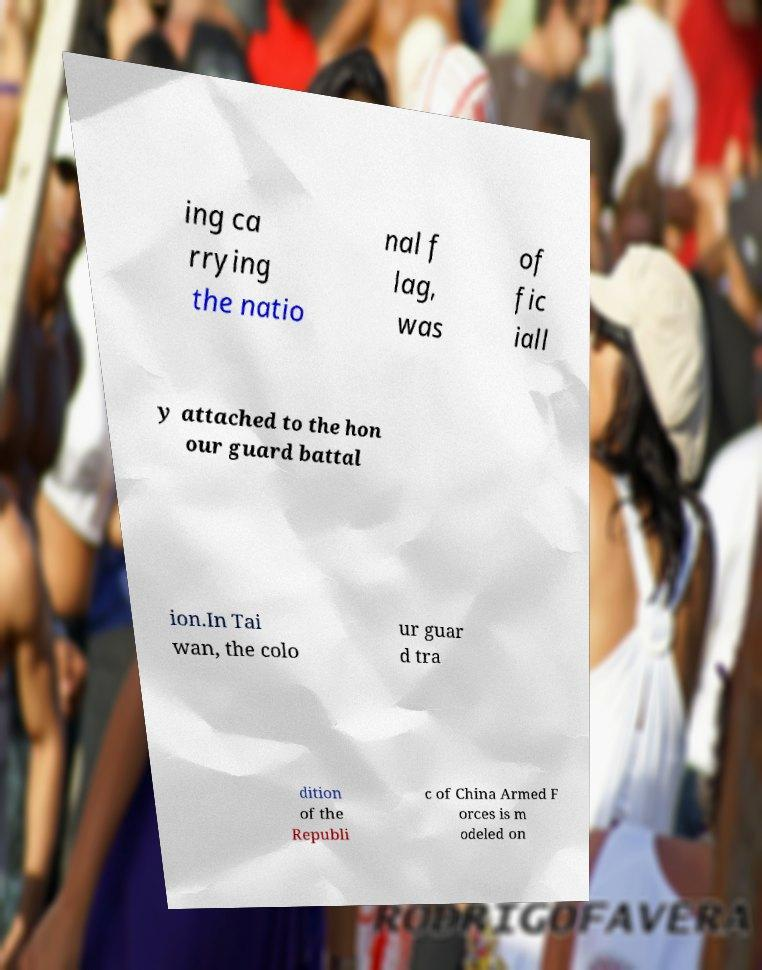What messages or text are displayed in this image? I need them in a readable, typed format. ing ca rrying the natio nal f lag, was of fic iall y attached to the hon our guard battal ion.In Tai wan, the colo ur guar d tra dition of the Republi c of China Armed F orces is m odeled on 